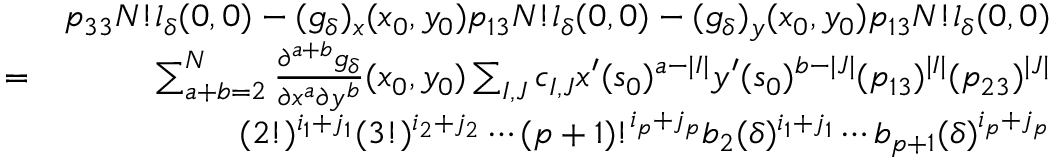<formula> <loc_0><loc_0><loc_500><loc_500>\begin{array} { r l r } & { p _ { 3 3 } N ! l _ { \delta } ( 0 , 0 ) - ( g _ { \delta } ) _ { x } ( x _ { 0 } , y _ { 0 } ) p _ { 1 3 } N ! l _ { \delta } ( 0 , 0 ) - ( g _ { \delta } ) _ { y } ( x _ { 0 } , y _ { 0 } ) p _ { 1 3 } N ! l _ { \delta } ( 0 , 0 ) } \\ & { = } & { \sum _ { a + b = 2 } ^ { N } \frac { \partial ^ { a + b } g _ { \delta } } { \partial x ^ { a } \partial y ^ { b } } ( x _ { 0 } , y _ { 0 } ) \sum _ { I , J } c _ { I , J } x ^ { \prime } ( s _ { 0 } ) ^ { a - | I | } y ^ { \prime } ( s _ { 0 } ) ^ { b - | J | } ( p _ { 1 3 } ) ^ { | I | } ( p _ { 2 3 } ) ^ { | J | } } \\ & { ( 2 ! ) ^ { i _ { 1 } + j _ { 1 } } ( 3 ! ) ^ { i _ { 2 } + j _ { 2 } } \cdots ( p + 1 ) ! ^ { i _ { p } + j _ { p } } b _ { 2 } ( \delta ) ^ { i _ { 1 } + j _ { 1 } } \cdots b _ { p + 1 } ( \delta ) ^ { i _ { p } + j _ { p } } } \end{array}</formula> 